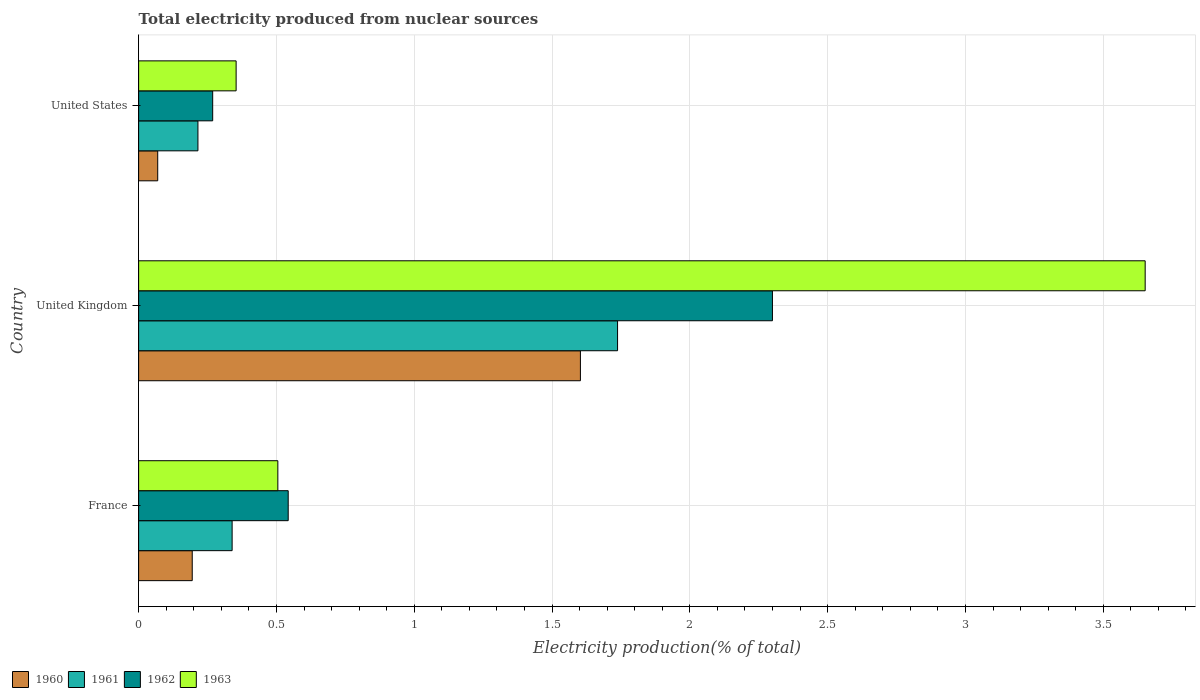How many different coloured bars are there?
Make the answer very short. 4. How many groups of bars are there?
Provide a succinct answer. 3. How many bars are there on the 1st tick from the top?
Your response must be concise. 4. How many bars are there on the 2nd tick from the bottom?
Keep it short and to the point. 4. What is the total electricity produced in 1961 in France?
Keep it short and to the point. 0.34. Across all countries, what is the maximum total electricity produced in 1962?
Give a very brief answer. 2.3. Across all countries, what is the minimum total electricity produced in 1960?
Provide a short and direct response. 0.07. What is the total total electricity produced in 1963 in the graph?
Provide a succinct answer. 4.51. What is the difference between the total electricity produced in 1962 in France and that in United States?
Ensure brevity in your answer.  0.27. What is the difference between the total electricity produced in 1963 in France and the total electricity produced in 1960 in United Kingdom?
Keep it short and to the point. -1.1. What is the average total electricity produced in 1960 per country?
Keep it short and to the point. 0.62. What is the difference between the total electricity produced in 1962 and total electricity produced in 1963 in France?
Your response must be concise. 0.04. What is the ratio of the total electricity produced in 1963 in United Kingdom to that in United States?
Offer a terse response. 10.32. Is the total electricity produced in 1961 in United Kingdom less than that in United States?
Keep it short and to the point. No. What is the difference between the highest and the second highest total electricity produced in 1961?
Make the answer very short. 1.4. What is the difference between the highest and the lowest total electricity produced in 1961?
Offer a very short reply. 1.52. Is the sum of the total electricity produced in 1960 in France and United States greater than the maximum total electricity produced in 1961 across all countries?
Your answer should be compact. No. What does the 4th bar from the top in United States represents?
Make the answer very short. 1960. What does the 4th bar from the bottom in United States represents?
Offer a very short reply. 1963. Is it the case that in every country, the sum of the total electricity produced in 1963 and total electricity produced in 1962 is greater than the total electricity produced in 1960?
Give a very brief answer. Yes. Are all the bars in the graph horizontal?
Provide a succinct answer. Yes. Does the graph contain any zero values?
Your response must be concise. No. Where does the legend appear in the graph?
Offer a terse response. Bottom left. How are the legend labels stacked?
Offer a very short reply. Horizontal. What is the title of the graph?
Provide a succinct answer. Total electricity produced from nuclear sources. What is the Electricity production(% of total) of 1960 in France?
Offer a terse response. 0.19. What is the Electricity production(% of total) in 1961 in France?
Your response must be concise. 0.34. What is the Electricity production(% of total) of 1962 in France?
Your answer should be compact. 0.54. What is the Electricity production(% of total) in 1963 in France?
Offer a terse response. 0.51. What is the Electricity production(% of total) of 1960 in United Kingdom?
Keep it short and to the point. 1.6. What is the Electricity production(% of total) of 1961 in United Kingdom?
Ensure brevity in your answer.  1.74. What is the Electricity production(% of total) of 1962 in United Kingdom?
Your answer should be very brief. 2.3. What is the Electricity production(% of total) of 1963 in United Kingdom?
Offer a very short reply. 3.65. What is the Electricity production(% of total) of 1960 in United States?
Your answer should be compact. 0.07. What is the Electricity production(% of total) in 1961 in United States?
Give a very brief answer. 0.22. What is the Electricity production(% of total) of 1962 in United States?
Ensure brevity in your answer.  0.27. What is the Electricity production(% of total) in 1963 in United States?
Your answer should be compact. 0.35. Across all countries, what is the maximum Electricity production(% of total) of 1960?
Give a very brief answer. 1.6. Across all countries, what is the maximum Electricity production(% of total) in 1961?
Your answer should be compact. 1.74. Across all countries, what is the maximum Electricity production(% of total) in 1962?
Offer a terse response. 2.3. Across all countries, what is the maximum Electricity production(% of total) of 1963?
Your answer should be compact. 3.65. Across all countries, what is the minimum Electricity production(% of total) in 1960?
Your answer should be very brief. 0.07. Across all countries, what is the minimum Electricity production(% of total) in 1961?
Give a very brief answer. 0.22. Across all countries, what is the minimum Electricity production(% of total) of 1962?
Provide a short and direct response. 0.27. Across all countries, what is the minimum Electricity production(% of total) in 1963?
Your answer should be compact. 0.35. What is the total Electricity production(% of total) of 1960 in the graph?
Provide a succinct answer. 1.87. What is the total Electricity production(% of total) in 1961 in the graph?
Your response must be concise. 2.29. What is the total Electricity production(% of total) of 1962 in the graph?
Make the answer very short. 3.11. What is the total Electricity production(% of total) of 1963 in the graph?
Ensure brevity in your answer.  4.51. What is the difference between the Electricity production(% of total) of 1960 in France and that in United Kingdom?
Give a very brief answer. -1.41. What is the difference between the Electricity production(% of total) of 1961 in France and that in United Kingdom?
Your answer should be compact. -1.4. What is the difference between the Electricity production(% of total) of 1962 in France and that in United Kingdom?
Provide a short and direct response. -1.76. What is the difference between the Electricity production(% of total) in 1963 in France and that in United Kingdom?
Offer a very short reply. -3.15. What is the difference between the Electricity production(% of total) of 1960 in France and that in United States?
Your response must be concise. 0.13. What is the difference between the Electricity production(% of total) in 1961 in France and that in United States?
Your answer should be compact. 0.12. What is the difference between the Electricity production(% of total) of 1962 in France and that in United States?
Provide a short and direct response. 0.27. What is the difference between the Electricity production(% of total) of 1963 in France and that in United States?
Make the answer very short. 0.15. What is the difference between the Electricity production(% of total) in 1960 in United Kingdom and that in United States?
Offer a terse response. 1.53. What is the difference between the Electricity production(% of total) of 1961 in United Kingdom and that in United States?
Your response must be concise. 1.52. What is the difference between the Electricity production(% of total) of 1962 in United Kingdom and that in United States?
Offer a very short reply. 2.03. What is the difference between the Electricity production(% of total) in 1963 in United Kingdom and that in United States?
Your answer should be very brief. 3.3. What is the difference between the Electricity production(% of total) in 1960 in France and the Electricity production(% of total) in 1961 in United Kingdom?
Make the answer very short. -1.54. What is the difference between the Electricity production(% of total) of 1960 in France and the Electricity production(% of total) of 1962 in United Kingdom?
Your response must be concise. -2.11. What is the difference between the Electricity production(% of total) of 1960 in France and the Electricity production(% of total) of 1963 in United Kingdom?
Keep it short and to the point. -3.46. What is the difference between the Electricity production(% of total) of 1961 in France and the Electricity production(% of total) of 1962 in United Kingdom?
Offer a terse response. -1.96. What is the difference between the Electricity production(% of total) in 1961 in France and the Electricity production(% of total) in 1963 in United Kingdom?
Your response must be concise. -3.31. What is the difference between the Electricity production(% of total) of 1962 in France and the Electricity production(% of total) of 1963 in United Kingdom?
Provide a succinct answer. -3.11. What is the difference between the Electricity production(% of total) in 1960 in France and the Electricity production(% of total) in 1961 in United States?
Give a very brief answer. -0.02. What is the difference between the Electricity production(% of total) of 1960 in France and the Electricity production(% of total) of 1962 in United States?
Your answer should be compact. -0.07. What is the difference between the Electricity production(% of total) of 1960 in France and the Electricity production(% of total) of 1963 in United States?
Provide a succinct answer. -0.16. What is the difference between the Electricity production(% of total) of 1961 in France and the Electricity production(% of total) of 1962 in United States?
Your answer should be very brief. 0.07. What is the difference between the Electricity production(% of total) in 1961 in France and the Electricity production(% of total) in 1963 in United States?
Your answer should be very brief. -0.01. What is the difference between the Electricity production(% of total) of 1962 in France and the Electricity production(% of total) of 1963 in United States?
Ensure brevity in your answer.  0.19. What is the difference between the Electricity production(% of total) of 1960 in United Kingdom and the Electricity production(% of total) of 1961 in United States?
Give a very brief answer. 1.39. What is the difference between the Electricity production(% of total) of 1960 in United Kingdom and the Electricity production(% of total) of 1962 in United States?
Your answer should be very brief. 1.33. What is the difference between the Electricity production(% of total) in 1960 in United Kingdom and the Electricity production(% of total) in 1963 in United States?
Provide a succinct answer. 1.25. What is the difference between the Electricity production(% of total) in 1961 in United Kingdom and the Electricity production(% of total) in 1962 in United States?
Offer a very short reply. 1.47. What is the difference between the Electricity production(% of total) of 1961 in United Kingdom and the Electricity production(% of total) of 1963 in United States?
Ensure brevity in your answer.  1.38. What is the difference between the Electricity production(% of total) in 1962 in United Kingdom and the Electricity production(% of total) in 1963 in United States?
Offer a terse response. 1.95. What is the average Electricity production(% of total) of 1960 per country?
Give a very brief answer. 0.62. What is the average Electricity production(% of total) in 1961 per country?
Provide a short and direct response. 0.76. What is the average Electricity production(% of total) in 1962 per country?
Provide a succinct answer. 1.04. What is the average Electricity production(% of total) of 1963 per country?
Ensure brevity in your answer.  1.5. What is the difference between the Electricity production(% of total) of 1960 and Electricity production(% of total) of 1961 in France?
Offer a terse response. -0.14. What is the difference between the Electricity production(% of total) in 1960 and Electricity production(% of total) in 1962 in France?
Provide a succinct answer. -0.35. What is the difference between the Electricity production(% of total) in 1960 and Electricity production(% of total) in 1963 in France?
Your answer should be very brief. -0.31. What is the difference between the Electricity production(% of total) of 1961 and Electricity production(% of total) of 1962 in France?
Offer a terse response. -0.2. What is the difference between the Electricity production(% of total) in 1961 and Electricity production(% of total) in 1963 in France?
Keep it short and to the point. -0.17. What is the difference between the Electricity production(% of total) of 1962 and Electricity production(% of total) of 1963 in France?
Your response must be concise. 0.04. What is the difference between the Electricity production(% of total) in 1960 and Electricity production(% of total) in 1961 in United Kingdom?
Your answer should be compact. -0.13. What is the difference between the Electricity production(% of total) in 1960 and Electricity production(% of total) in 1962 in United Kingdom?
Keep it short and to the point. -0.7. What is the difference between the Electricity production(% of total) in 1960 and Electricity production(% of total) in 1963 in United Kingdom?
Keep it short and to the point. -2.05. What is the difference between the Electricity production(% of total) in 1961 and Electricity production(% of total) in 1962 in United Kingdom?
Make the answer very short. -0.56. What is the difference between the Electricity production(% of total) of 1961 and Electricity production(% of total) of 1963 in United Kingdom?
Provide a short and direct response. -1.91. What is the difference between the Electricity production(% of total) of 1962 and Electricity production(% of total) of 1963 in United Kingdom?
Provide a short and direct response. -1.35. What is the difference between the Electricity production(% of total) in 1960 and Electricity production(% of total) in 1961 in United States?
Your answer should be compact. -0.15. What is the difference between the Electricity production(% of total) in 1960 and Electricity production(% of total) in 1962 in United States?
Provide a short and direct response. -0.2. What is the difference between the Electricity production(% of total) of 1960 and Electricity production(% of total) of 1963 in United States?
Your answer should be very brief. -0.28. What is the difference between the Electricity production(% of total) in 1961 and Electricity production(% of total) in 1962 in United States?
Ensure brevity in your answer.  -0.05. What is the difference between the Electricity production(% of total) in 1961 and Electricity production(% of total) in 1963 in United States?
Give a very brief answer. -0.14. What is the difference between the Electricity production(% of total) in 1962 and Electricity production(% of total) in 1963 in United States?
Your answer should be very brief. -0.09. What is the ratio of the Electricity production(% of total) of 1960 in France to that in United Kingdom?
Offer a very short reply. 0.12. What is the ratio of the Electricity production(% of total) of 1961 in France to that in United Kingdom?
Ensure brevity in your answer.  0.2. What is the ratio of the Electricity production(% of total) of 1962 in France to that in United Kingdom?
Give a very brief answer. 0.24. What is the ratio of the Electricity production(% of total) of 1963 in France to that in United Kingdom?
Provide a short and direct response. 0.14. What is the ratio of the Electricity production(% of total) of 1960 in France to that in United States?
Keep it short and to the point. 2.81. What is the ratio of the Electricity production(% of total) in 1961 in France to that in United States?
Offer a terse response. 1.58. What is the ratio of the Electricity production(% of total) in 1962 in France to that in United States?
Ensure brevity in your answer.  2.02. What is the ratio of the Electricity production(% of total) of 1963 in France to that in United States?
Make the answer very short. 1.43. What is the ratio of the Electricity production(% of total) in 1960 in United Kingdom to that in United States?
Give a very brief answer. 23.14. What is the ratio of the Electricity production(% of total) in 1961 in United Kingdom to that in United States?
Your response must be concise. 8.08. What is the ratio of the Electricity production(% of total) in 1962 in United Kingdom to that in United States?
Keep it short and to the point. 8.56. What is the ratio of the Electricity production(% of total) in 1963 in United Kingdom to that in United States?
Your response must be concise. 10.32. What is the difference between the highest and the second highest Electricity production(% of total) of 1960?
Keep it short and to the point. 1.41. What is the difference between the highest and the second highest Electricity production(% of total) in 1961?
Your answer should be very brief. 1.4. What is the difference between the highest and the second highest Electricity production(% of total) in 1962?
Keep it short and to the point. 1.76. What is the difference between the highest and the second highest Electricity production(% of total) in 1963?
Give a very brief answer. 3.15. What is the difference between the highest and the lowest Electricity production(% of total) in 1960?
Offer a very short reply. 1.53. What is the difference between the highest and the lowest Electricity production(% of total) of 1961?
Ensure brevity in your answer.  1.52. What is the difference between the highest and the lowest Electricity production(% of total) in 1962?
Give a very brief answer. 2.03. What is the difference between the highest and the lowest Electricity production(% of total) of 1963?
Offer a very short reply. 3.3. 